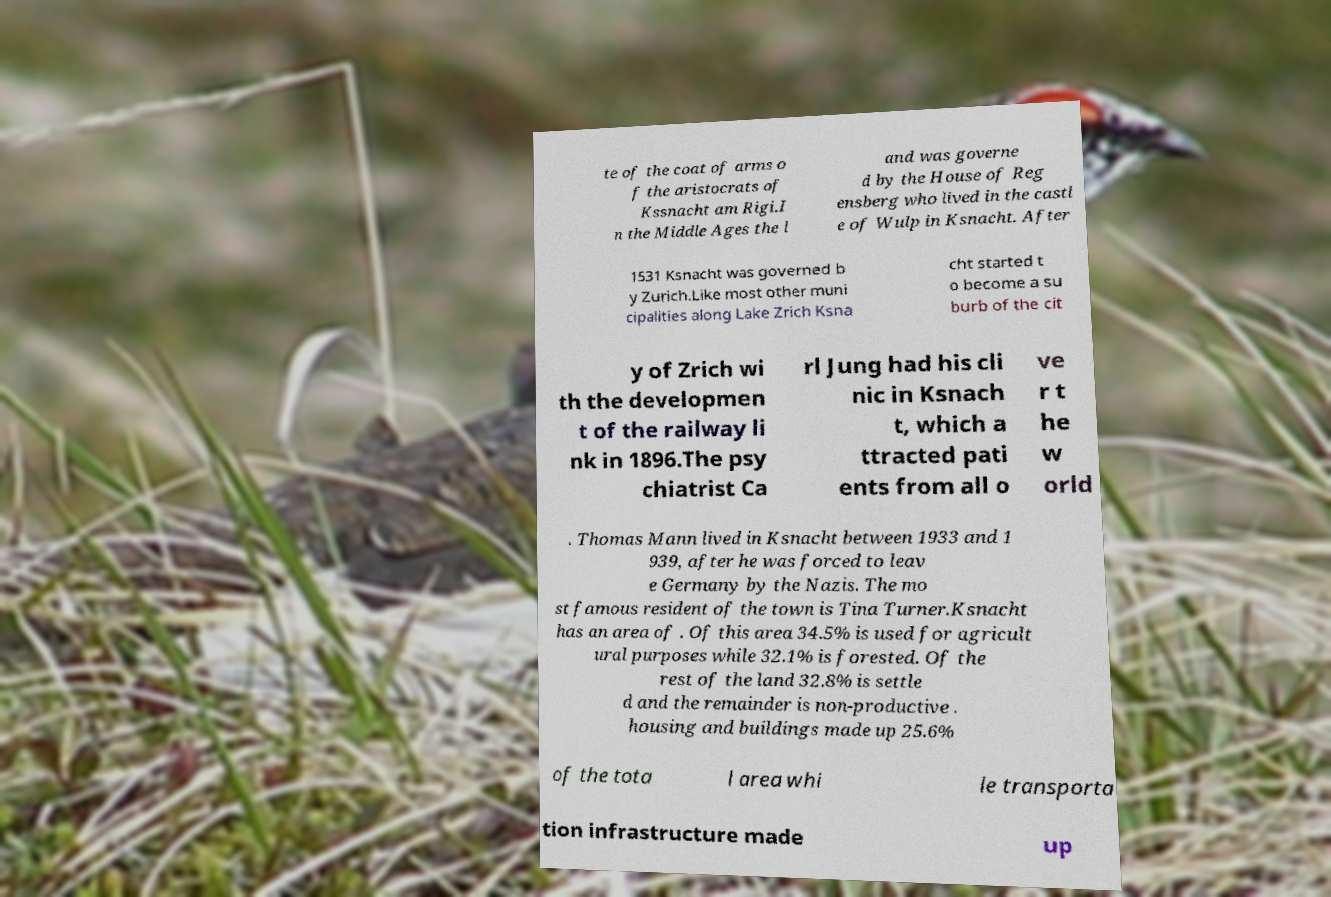What messages or text are displayed in this image? I need them in a readable, typed format. te of the coat of arms o f the aristocrats of Kssnacht am Rigi.I n the Middle Ages the l and was governe d by the House of Reg ensberg who lived in the castl e of Wulp in Ksnacht. After 1531 Ksnacht was governed b y Zurich.Like most other muni cipalities along Lake Zrich Ksna cht started t o become a su burb of the cit y of Zrich wi th the developmen t of the railway li nk in 1896.The psy chiatrist Ca rl Jung had his cli nic in Ksnach t, which a ttracted pati ents from all o ve r t he w orld . Thomas Mann lived in Ksnacht between 1933 and 1 939, after he was forced to leav e Germany by the Nazis. The mo st famous resident of the town is Tina Turner.Ksnacht has an area of . Of this area 34.5% is used for agricult ural purposes while 32.1% is forested. Of the rest of the land 32.8% is settle d and the remainder is non-productive . housing and buildings made up 25.6% of the tota l area whi le transporta tion infrastructure made up 